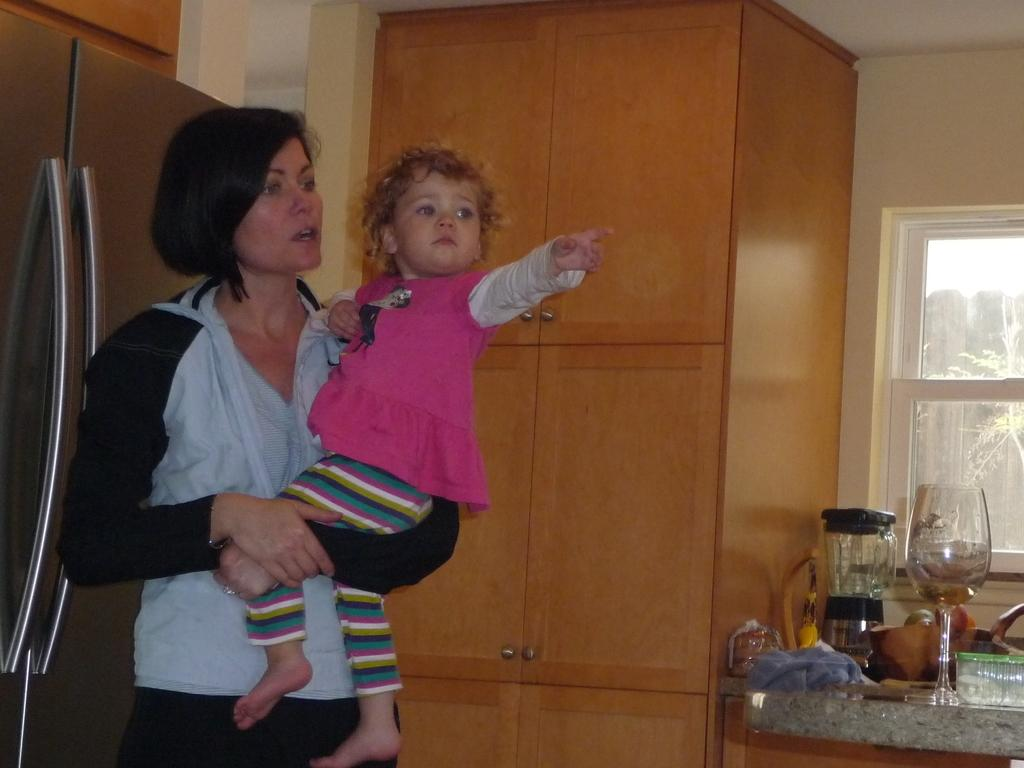Who is present in the image? There is a woman in the image. What is the woman doing in the image? The woman is holding a kid. What type of furniture can be seen in the image? There is a wooden wardrobe and a table in the image. What is on the table in the image? There is a glass on the table. What can be seen through the window in the image? The window is not clear enough to see through in the image. What type of rings can be seen on the woman's fingers in the image? There are no rings visible on the woman's fingers in the image. What type of band is playing in the background of the image? There is no band present in the image. 